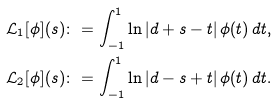<formula> <loc_0><loc_0><loc_500><loc_500>& \mathcal { L } _ { 1 } [ \phi ] ( s ) \colon = \int ^ { 1 } _ { - 1 } \ln | d + s - t | \, \phi ( t ) \, d t , \\ & \mathcal { L } _ { 2 } [ \phi ] ( s ) \colon = \int ^ { 1 } _ { - 1 } \ln | d - s + t | \, \phi ( t ) \, d t .</formula> 